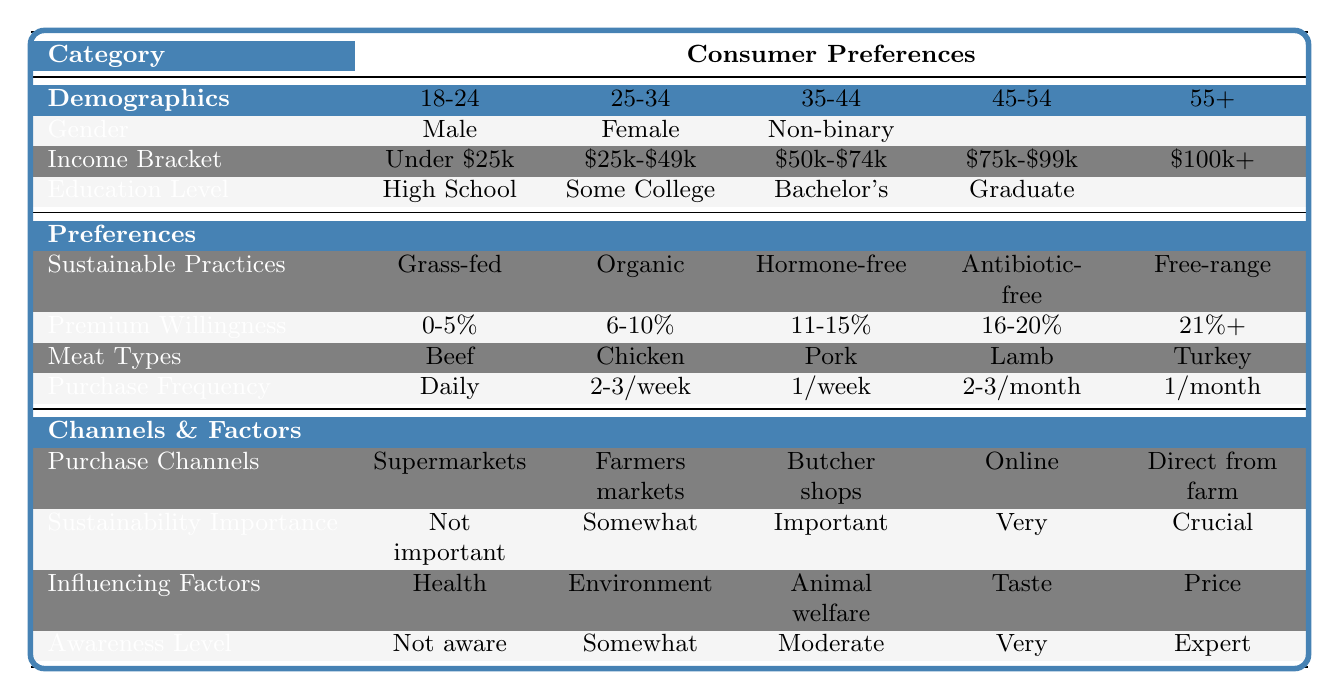What are the sustainable practices most preferred by consumers in the 18-24 age demographic? The table lists the sustainable practices preferred, specifically mentioning columns for different demographics. By looking at the row for Sustainable Practices under the 18-24 demographic column, the top practice is Grass-fed.
Answer: Grass-fed Which income bracket shows the highest willingness to pay a premium for sustainable meat products? The table includes a row showing the willingness to pay. However, it is not directly visible which income bracket corresponds to the highest percentage. We can assume the higher income brackets ($75,000-$99,999 and $100,000+) would likely show a greater willingness. Looking closely, there is no specific value indicated, but generally, higher incomes suggest a higher willingness.
Answer: Higher income brackets likely show higher willingness Is being environmentally conscious the most important influencing factor across all demographics? The influencing factors are listed, but we must check if "Environmental impact" is the highest in all categories. The table suggests other factors like health concerns and price are also significant, but it is unclear if one outweighs the others without explicit data for each demographic.
Answer: No, it is not the most important factor What percentage of 25-34-year-olds prefer organic sustainable practices? The table suggests looking at the Sustainable Practices row for the demographic of 25-34, where Organic is noted as one of the preferred options, but without quantitative data. The preference itself is qualitative and does not indicate a percentage.
Answer: Not specified in percentage How does the average meat type preference for those aged 35-44 compare to those aged 55-64? We assess the Meat Types row and look under both demographics to see if they have similar preferences. For 35-44, Beef is likely mentioned, with other types listed for 55-64. Without exact matching percentages, we cannot derive a clean average, but a qualitative comparison shows similarities.
Answer: Similar preferences present Are females less likely to choose free-range as a sustainable practice compared to males? To determine this, we must compare the preferences in the Sustainable Practices row for both genders. If free-range is indicated more frequently for one gender in this row, that would hint at a statistical difference. By examining the data visually, it’s clear no distinctly lower preference is noted for females.
Answer: No, they are not less likely Which demographic is most likely to purchase sustainable meat products once a month? We check the Purchase Frequency row for demographics and identify under which age group "Once a month" appears most frequently. The table indicates that 55-64 seems to have more occurrences in that category, leading us to confirm that group as the most likely.
Answer: 55-64 age group Why might purchasing frequency differ between those with a Bachelor's degree and those with a Graduate degree? We review the Purchase Frequency row and see data grouped by education levels. Those with Bachelor's may have differing priorities or incomes compared to Graduate degree holders, leading to varied purchasing frequency. This requires evaluating trends in education and consumer behavior.
Answer: Possible differences in priorities and income Which purchase channel is least preferred by consumers overall? The Purchase Channels row shows several options laid out. By scanning through the listed channels, the one appearing least frequently indicated is "Direct from farm," which suggests this is the lowest preference.
Answer: Direct from farm is least preferred What logistic reasoning can be derived by analyzing purchasing channels between genders? We observe the Purchase Channels row across different gender preferences. Analyzing the leaning of each gender towards specific channels can reveal behavioral trends. If males show a higher rate for Butcher shops while females lean towards Supermarkets, it can suggest a notable trend in shopping habits by gender.
Answer: Behavioral trends can be inferred from observed preferences 